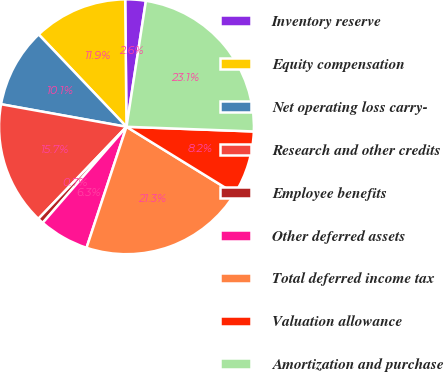<chart> <loc_0><loc_0><loc_500><loc_500><pie_chart><fcel>Inventory reserve<fcel>Equity compensation<fcel>Net operating loss carry-<fcel>Research and other credits<fcel>Employee benefits<fcel>Other deferred assets<fcel>Total deferred income tax<fcel>Valuation allowance<fcel>Amortization and purchase<nl><fcel>2.6%<fcel>11.94%<fcel>10.07%<fcel>15.68%<fcel>0.74%<fcel>6.34%<fcel>21.28%<fcel>8.21%<fcel>23.15%<nl></chart> 